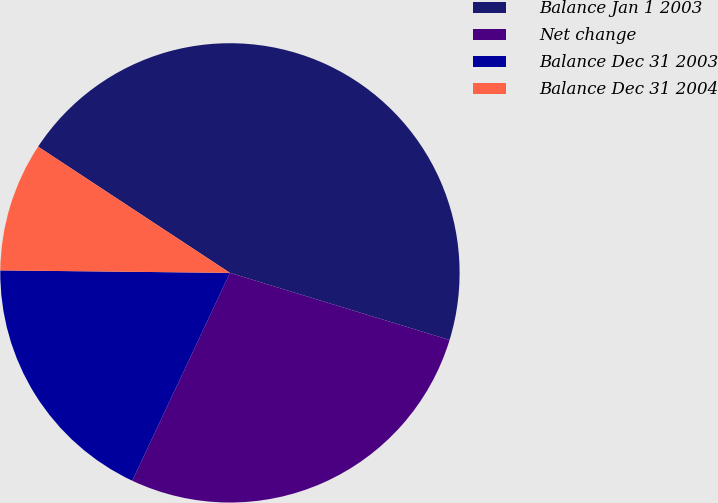Convert chart to OTSL. <chart><loc_0><loc_0><loc_500><loc_500><pie_chart><fcel>Balance Jan 1 2003<fcel>Net change<fcel>Balance Dec 31 2003<fcel>Balance Dec 31 2004<nl><fcel>45.45%<fcel>27.27%<fcel>18.18%<fcel>9.09%<nl></chart> 